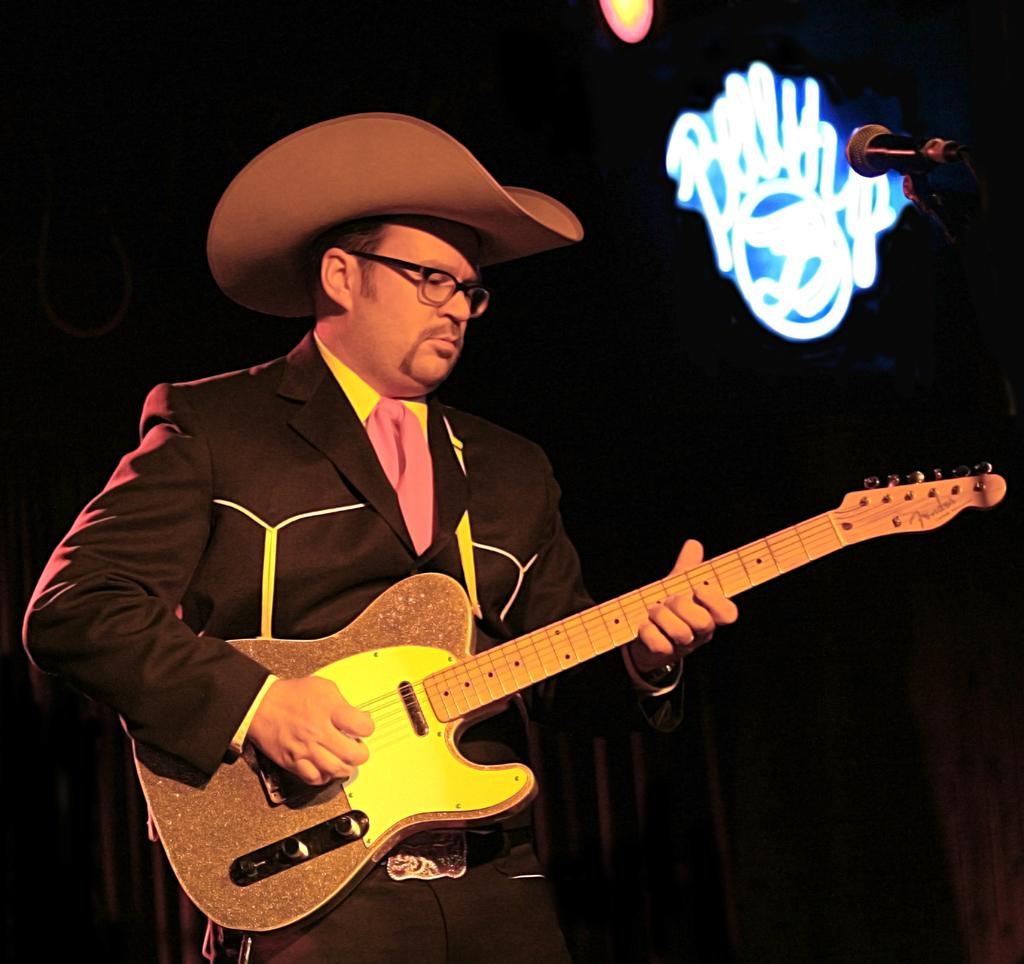What is the man in the image doing? The man is playing a guitar in the image. What is the man wearing on his head? The man is wearing a hat in the image. Can you see any pigs or cheese on the farm in the image? There is no farm, pig, or cheese present in the image; it features a man playing a guitar while wearing a hat. 